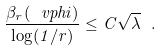Convert formula to latex. <formula><loc_0><loc_0><loc_500><loc_500>\frac { \beta _ { r } ( \ v p h i ) } { \log ( 1 / r ) } \leq C \sqrt { \lambda } \ .</formula> 